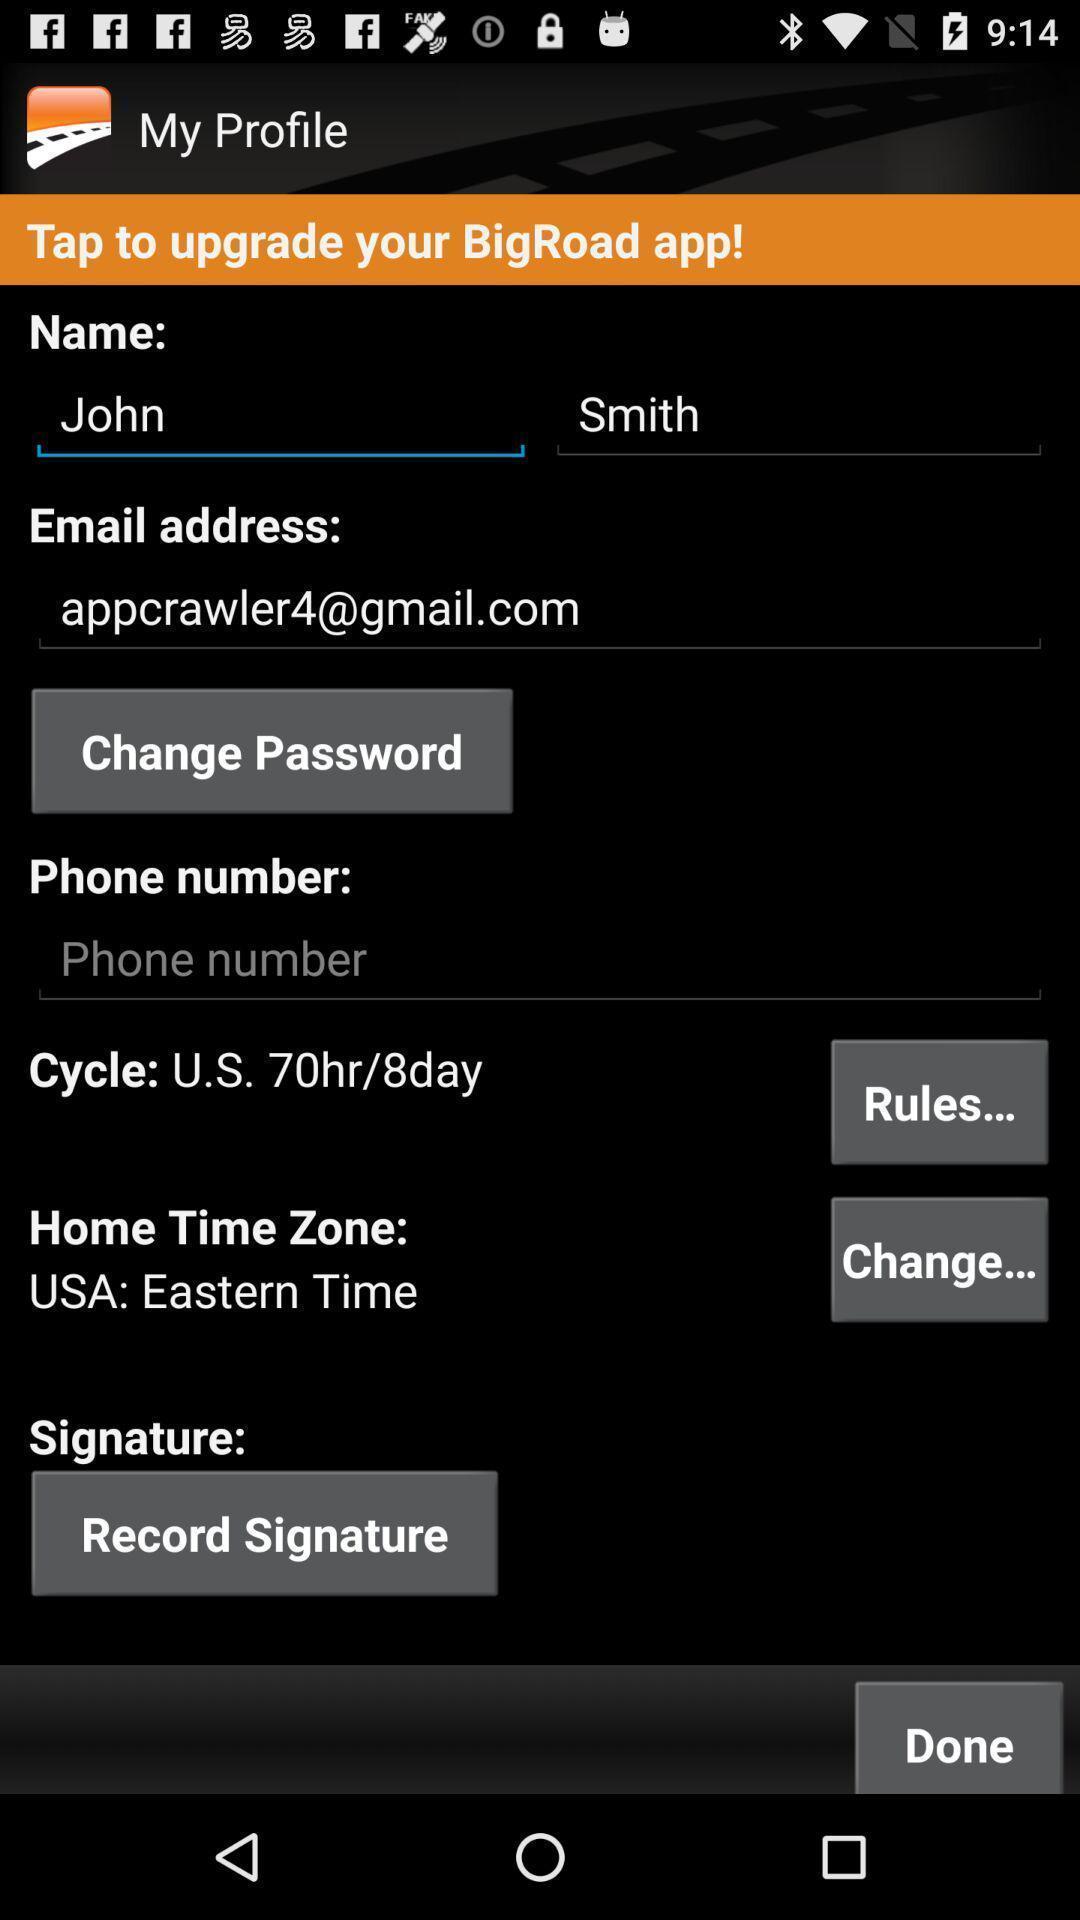Describe the key features of this screenshot. Page displaying with entry details to setup for the profile. 